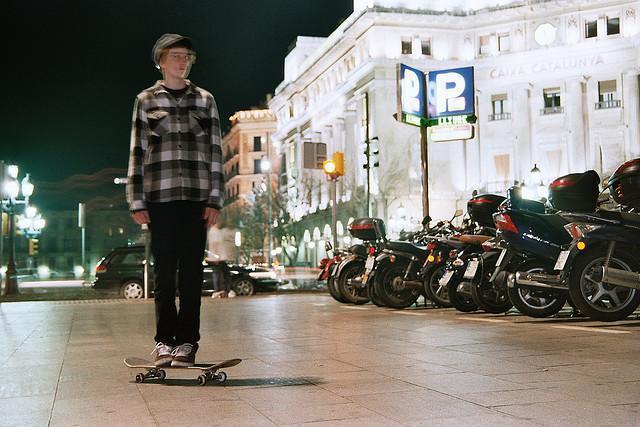How many motorcycles are in the photo?
Give a very brief answer. 6. 